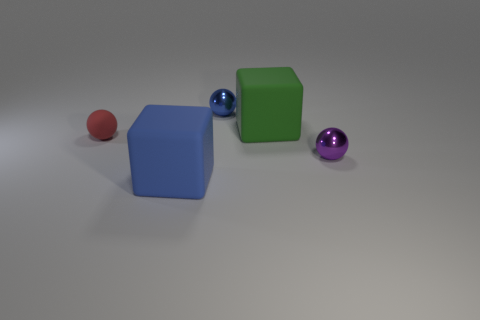What is the shape of the big object that is behind the tiny metal thing that is in front of the tiny ball that is to the left of the big blue block?
Your answer should be very brief. Cube. What number of things are either balls behind the large green matte cube or small shiny objects that are left of the purple shiny sphere?
Make the answer very short. 1. Does the green rubber block have the same size as the blue object that is behind the green rubber thing?
Provide a succinct answer. No. Is the object to the right of the green matte block made of the same material as the tiny thing that is behind the red rubber ball?
Offer a terse response. Yes. Are there an equal number of green things in front of the green cube and metal objects that are behind the red matte ball?
Provide a succinct answer. No. How many metal objects are purple spheres or small blue objects?
Your response must be concise. 2. There is a small object that is to the right of the green rubber block; is its shape the same as the rubber thing to the left of the big blue thing?
Your answer should be compact. Yes. There is a blue cube; how many large rubber objects are on the right side of it?
Keep it short and to the point. 1. Is there a small blue ball made of the same material as the blue cube?
Offer a very short reply. No. There is a object that is the same size as the blue cube; what is it made of?
Ensure brevity in your answer.  Rubber. 